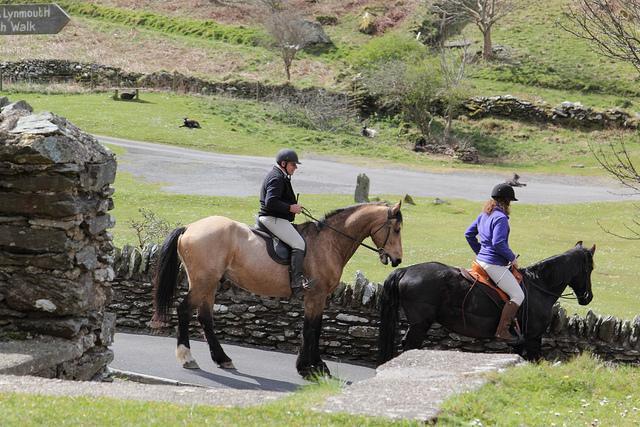What are the black helmets the people are wearing made for?
Answer the question by selecting the correct answer among the 4 following choices and explain your choice with a short sentence. The answer should be formatted with the following format: `Answer: choice
Rationale: rationale.`
Options: Halloween, style, riding, sweat reduction. Answer: riding.
Rationale: The men are on horses and have helmets on in case they fall. 